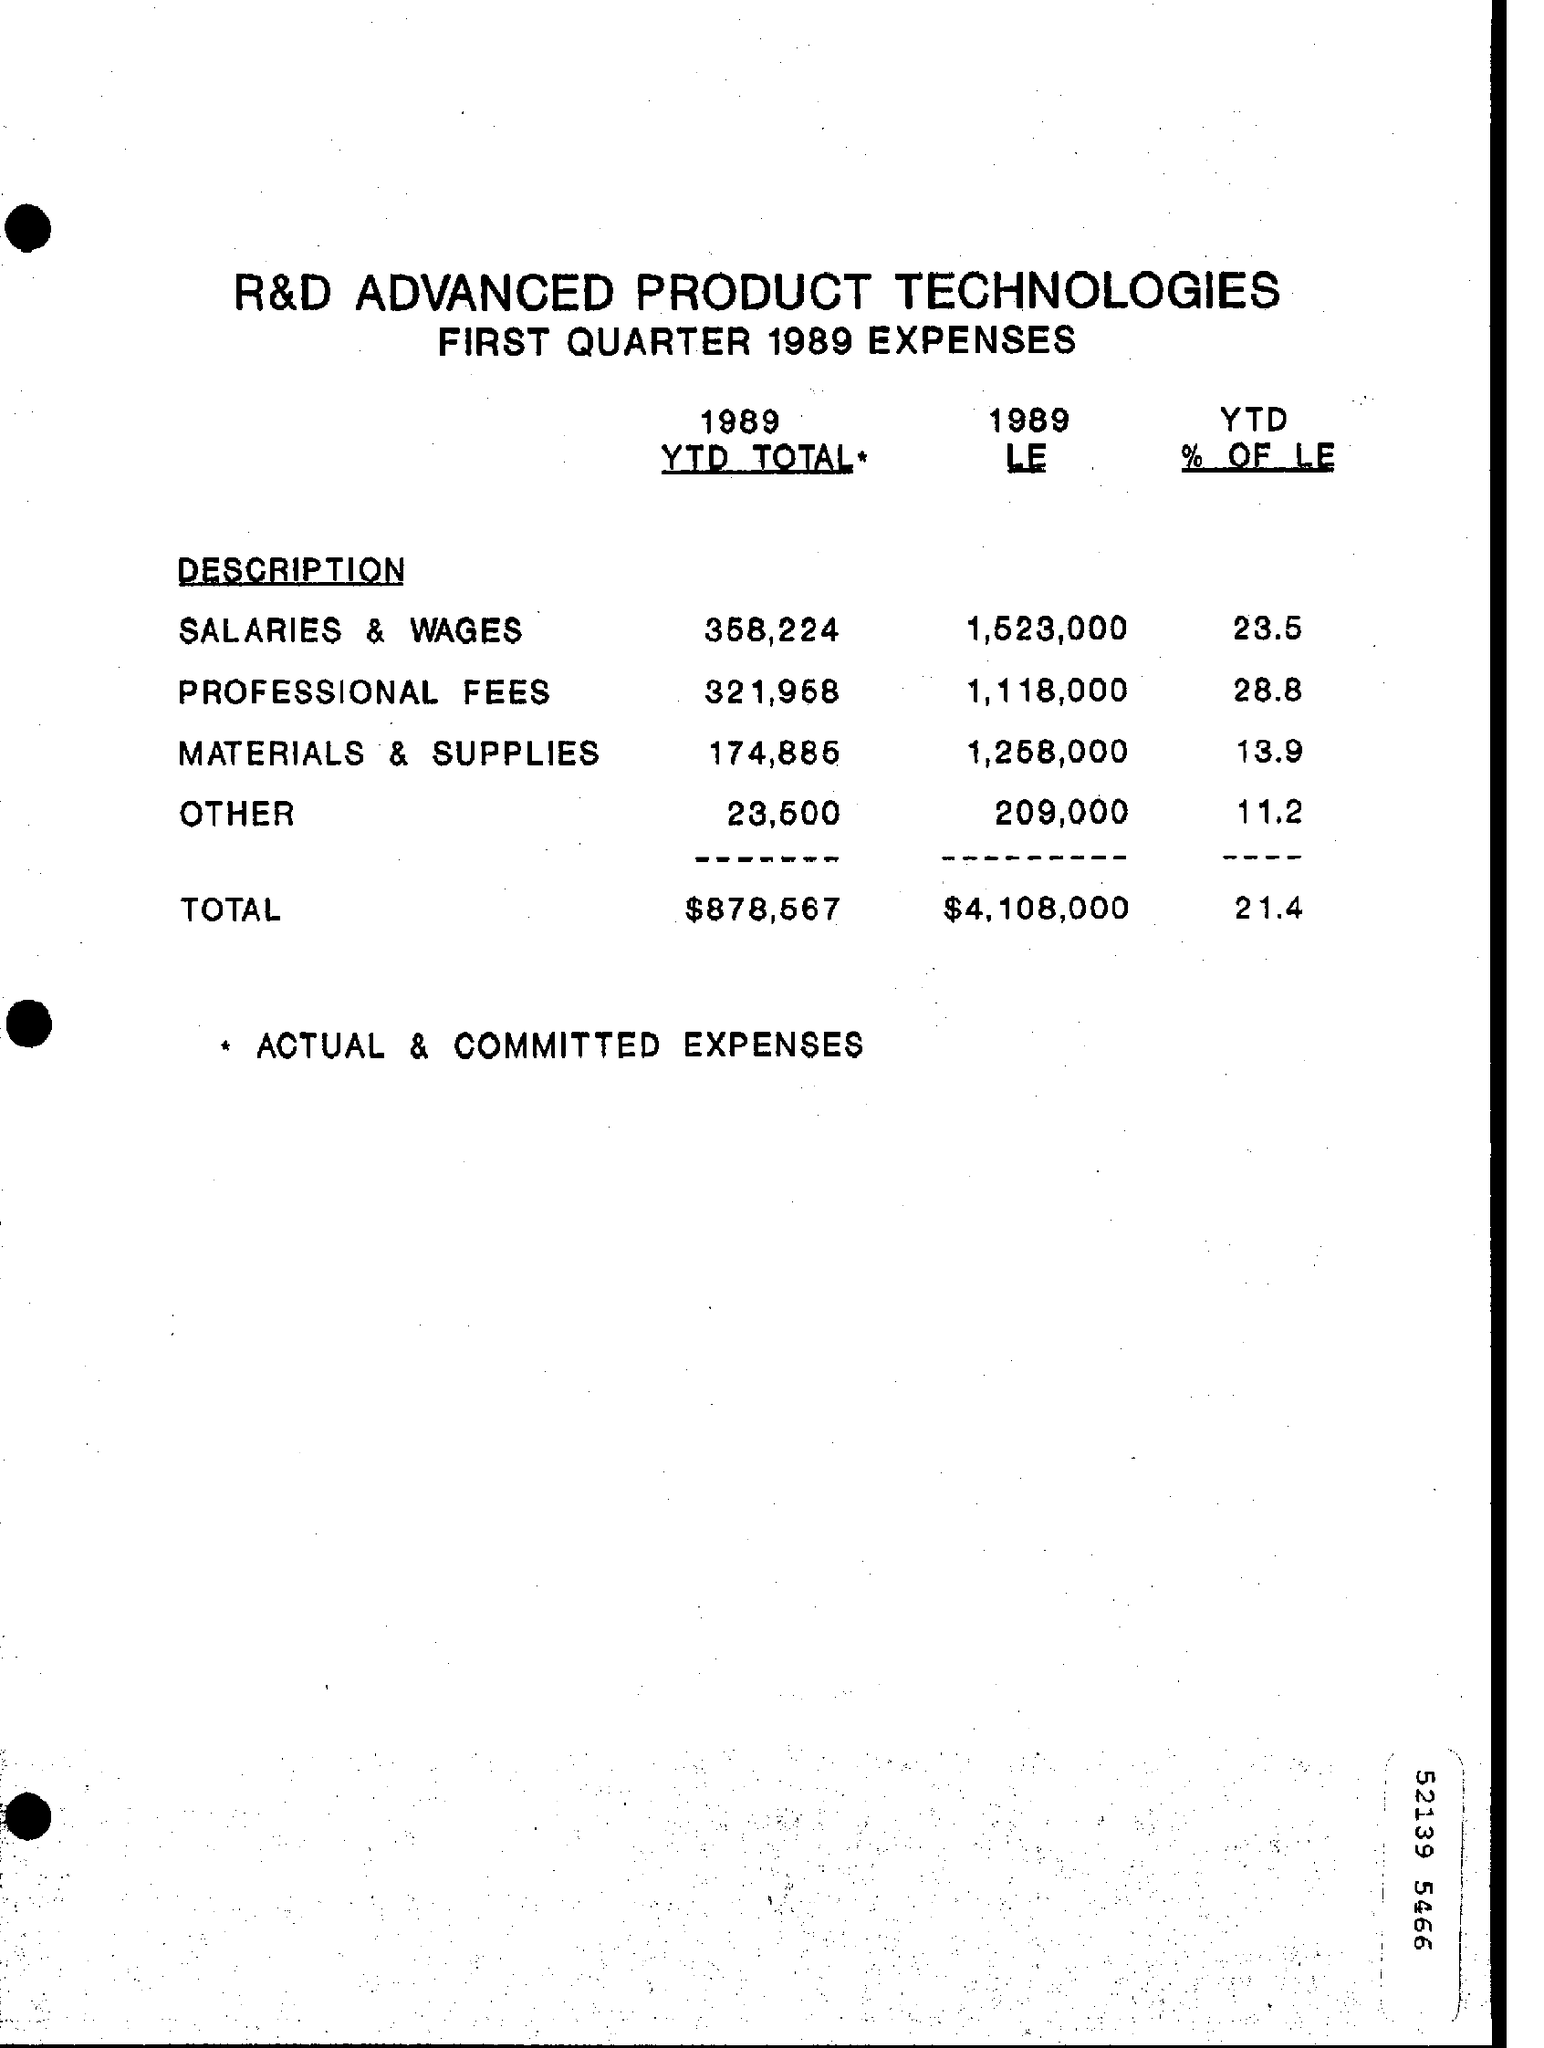Which year's expenses is mentioned in this document?
Keep it short and to the point. 1989. How much is the '1989 YTD TOTAL' for 'SALARIES & WAGES' ?
Provide a short and direct response. 358,224. What is the TOTAL 'YTD % of LE' ?
Ensure brevity in your answer.  21.4. What * symbol represents ?
Keep it short and to the point. ACTUAL & COMMITTED EXPENSES. Which 'Description' head has lowest expense in '1989 LE' ?
Ensure brevity in your answer.  OTHER. Which 'Description' head has hightest expense in '1989 LE' ?
Offer a very short reply. Salaries & wages. Which is the highest percentage value in 'YTD % OF LE' column?
Offer a terse response. 28.8. What is the ' 1989 LE ' value of Description "MATERIALS & SUPPLIES" ?
Make the answer very short. 1,258,000. 